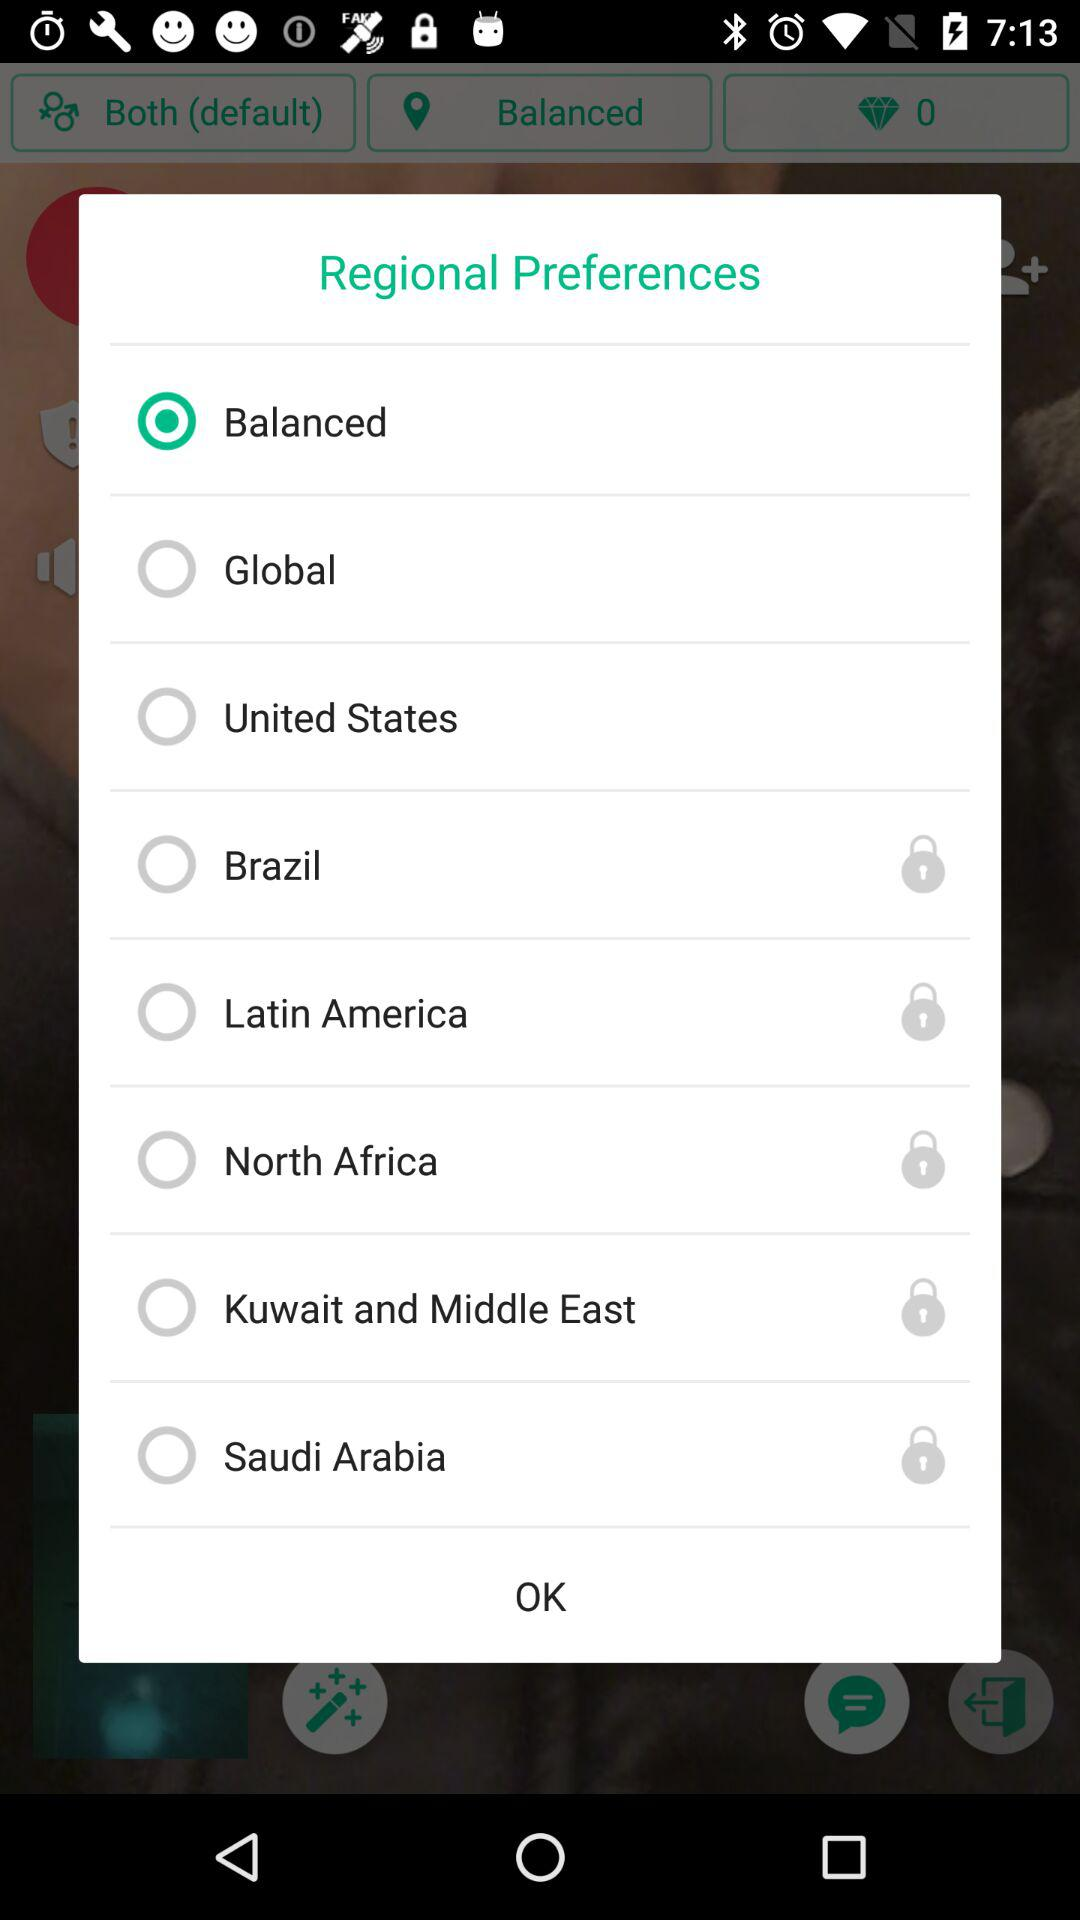Is "Brazil" selected or not? "Brazil" is not selected. 